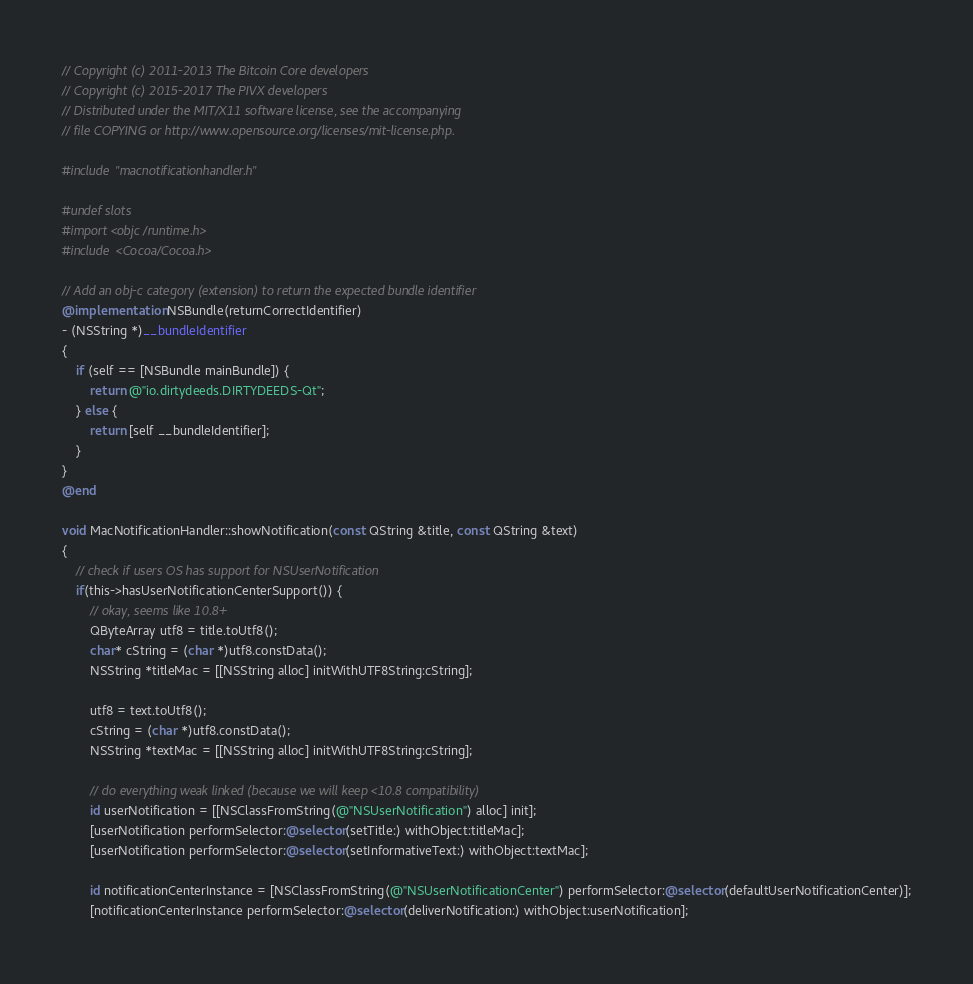Convert code to text. <code><loc_0><loc_0><loc_500><loc_500><_ObjectiveC_>// Copyright (c) 2011-2013 The Bitcoin Core developers
// Copyright (c) 2015-2017 The PIVX developers
// Distributed under the MIT/X11 software license, see the accompanying
// file COPYING or http://www.opensource.org/licenses/mit-license.php.

#include "macnotificationhandler.h"

#undef slots
#import <objc/runtime.h>
#include <Cocoa/Cocoa.h>

// Add an obj-c category (extension) to return the expected bundle identifier
@implementation NSBundle(returnCorrectIdentifier)
- (NSString *)__bundleIdentifier
{
    if (self == [NSBundle mainBundle]) {
        return @"io.dirtydeeds.DIRTYDEEDS-Qt";
    } else {
        return [self __bundleIdentifier];
    }
}
@end

void MacNotificationHandler::showNotification(const QString &title, const QString &text)
{
    // check if users OS has support for NSUserNotification
    if(this->hasUserNotificationCenterSupport()) {
        // okay, seems like 10.8+
        QByteArray utf8 = title.toUtf8();
        char* cString = (char *)utf8.constData();
        NSString *titleMac = [[NSString alloc] initWithUTF8String:cString];

        utf8 = text.toUtf8();
        cString = (char *)utf8.constData();
        NSString *textMac = [[NSString alloc] initWithUTF8String:cString];

        // do everything weak linked (because we will keep <10.8 compatibility)
        id userNotification = [[NSClassFromString(@"NSUserNotification") alloc] init];
        [userNotification performSelector:@selector(setTitle:) withObject:titleMac];
        [userNotification performSelector:@selector(setInformativeText:) withObject:textMac];

        id notificationCenterInstance = [NSClassFromString(@"NSUserNotificationCenter") performSelector:@selector(defaultUserNotificationCenter)];
        [notificationCenterInstance performSelector:@selector(deliverNotification:) withObject:userNotification];
</code> 